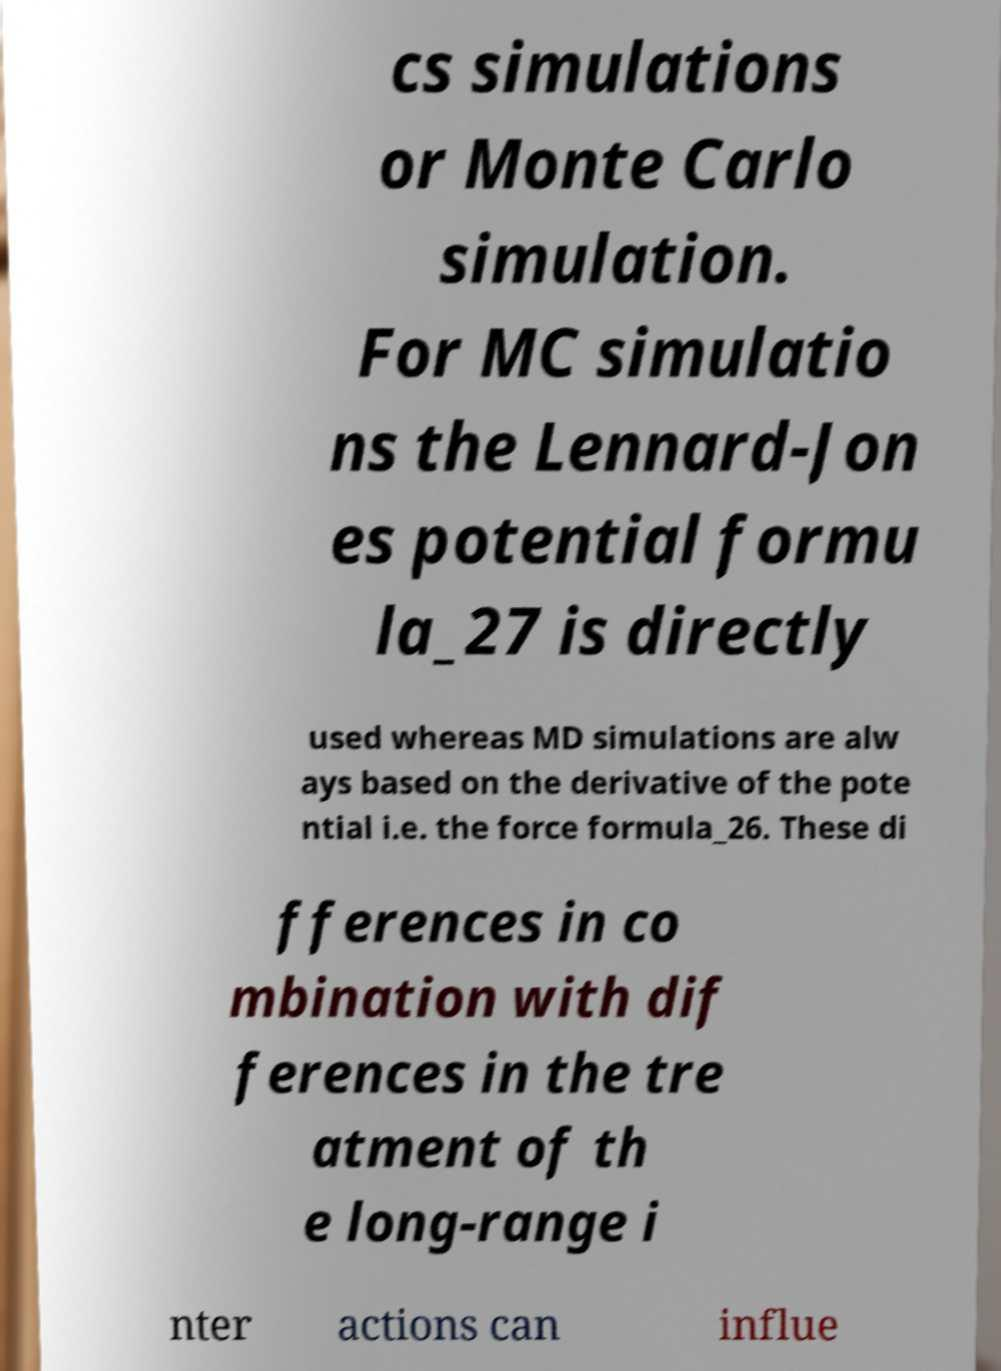Please read and relay the text visible in this image. What does it say? cs simulations or Monte Carlo simulation. For MC simulatio ns the Lennard-Jon es potential formu la_27 is directly used whereas MD simulations are alw ays based on the derivative of the pote ntial i.e. the force formula_26. These di fferences in co mbination with dif ferences in the tre atment of th e long-range i nter actions can influe 